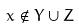<formula> <loc_0><loc_0><loc_500><loc_500>x \notin Y \cup Z</formula> 